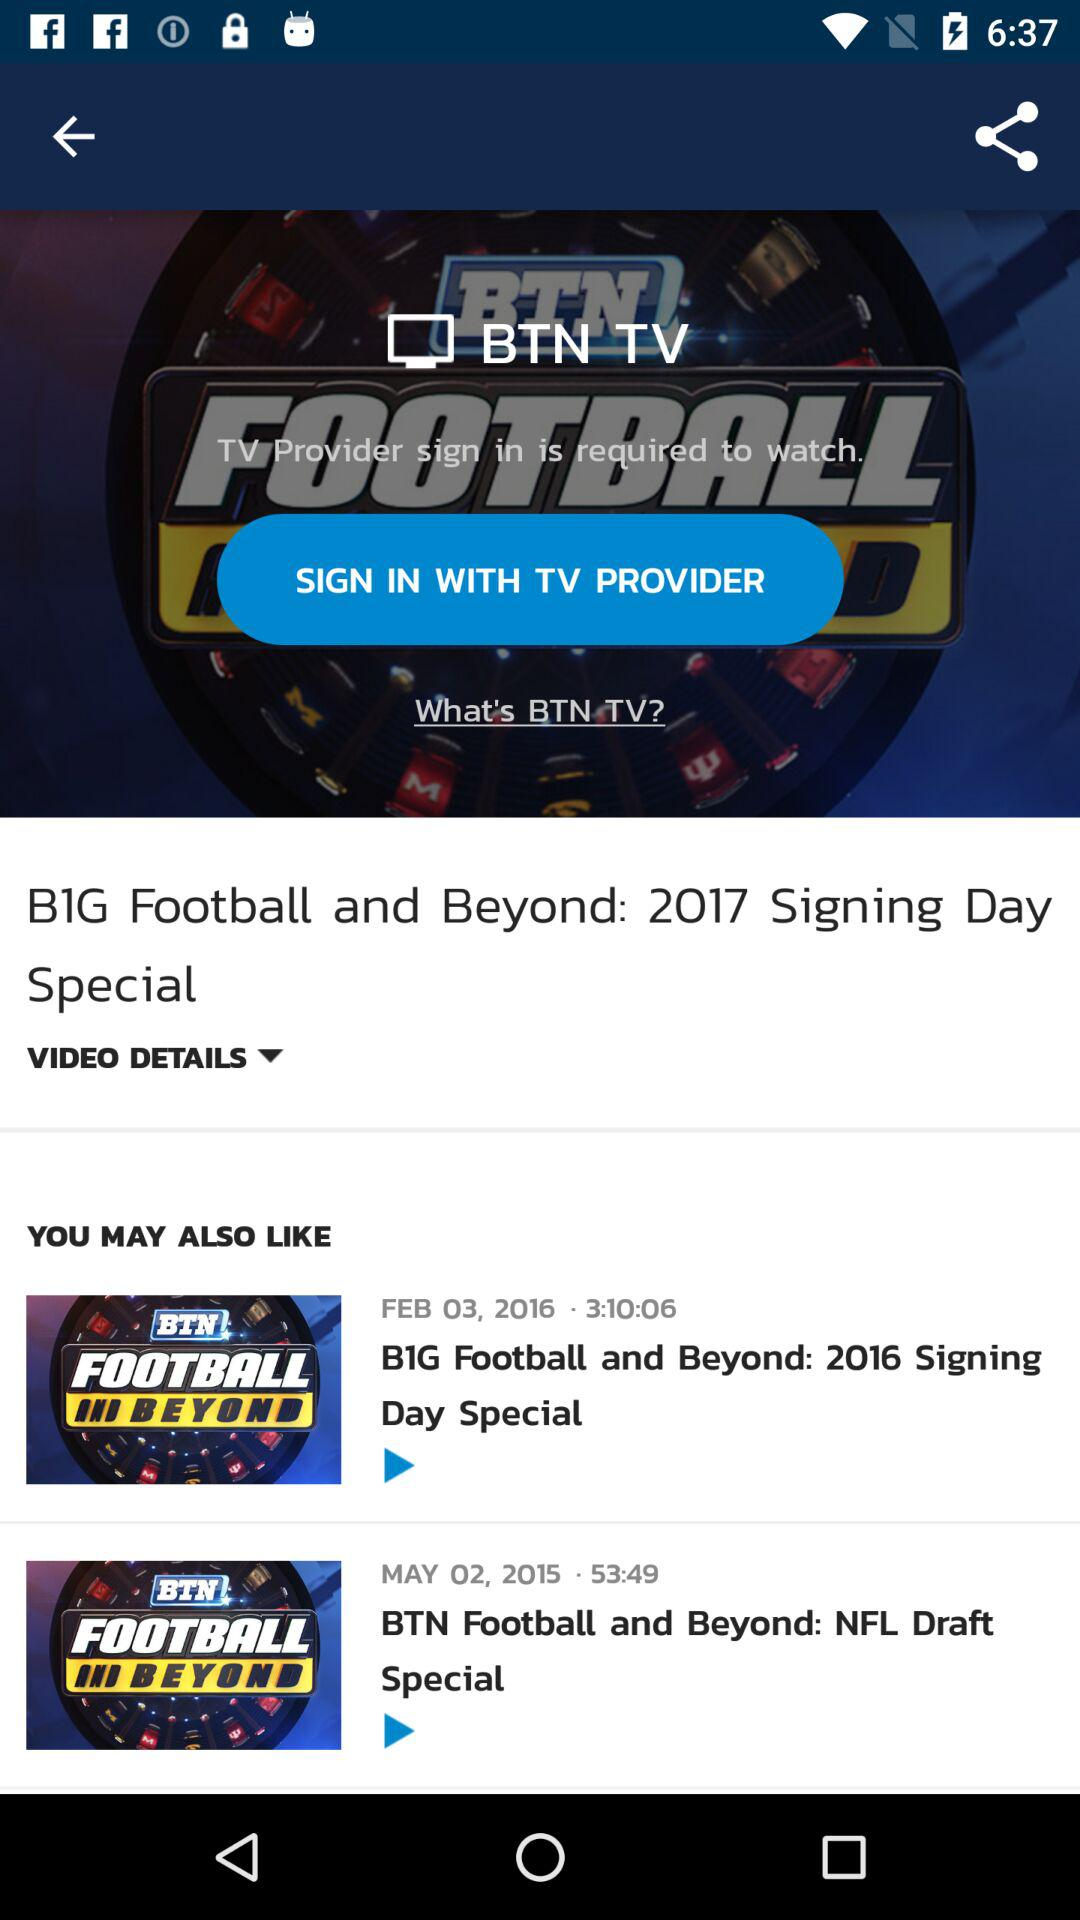What is the name of the application? The name of the application is "BTN TV". 